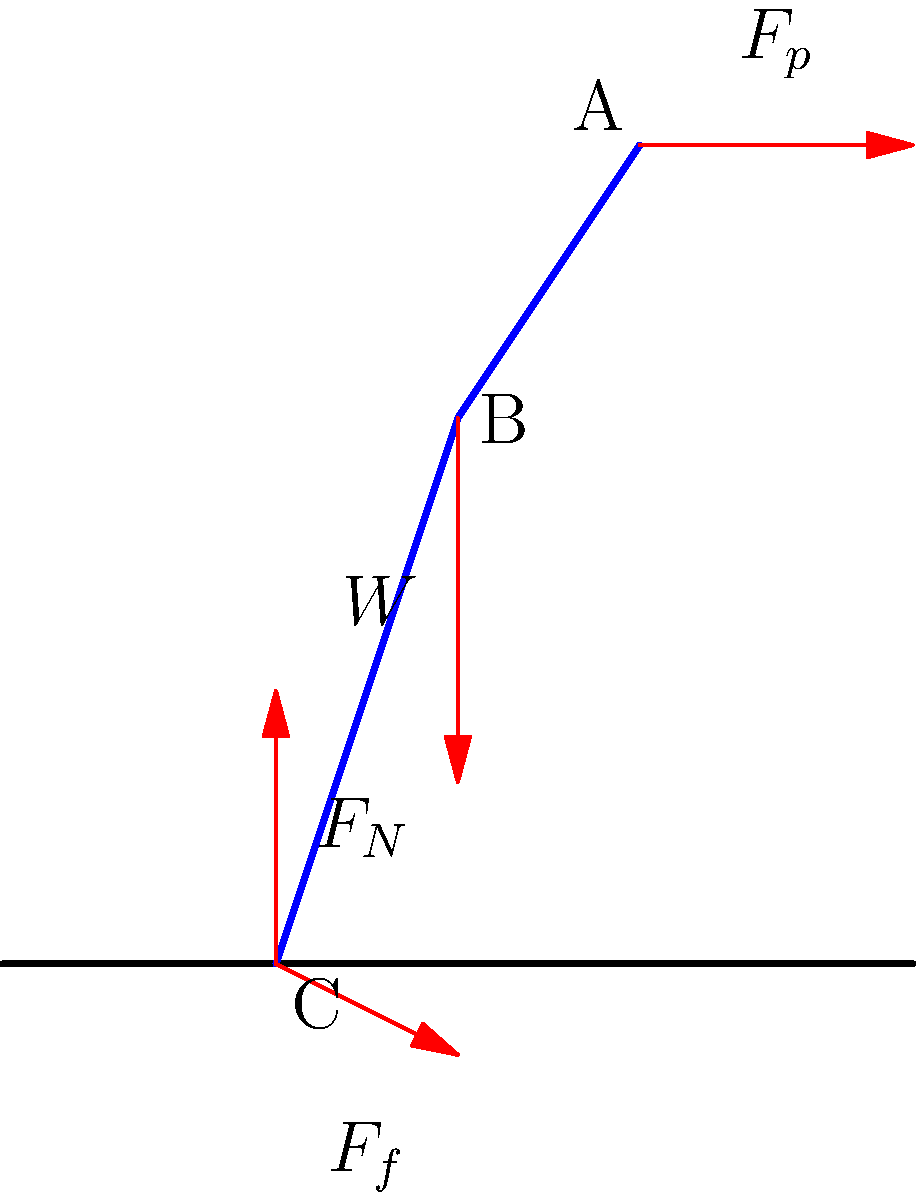In the force diagram of a runner's leg during the stance phase, which force is responsible for propelling the runner forward, and how does it relate to the concept of ground reaction force in biomechanics? To answer this question, let's analyze the force diagram step-by-step:

1. The diagram shows four main forces acting on the runner's leg during the stance phase:
   - $F_N$: Normal force (vertical)
   - $F_f$: Friction force (horizontal)
   - $W$: Weight of the body
   - $F_p$: Propulsive force

2. The ground reaction force (GRF) is the force exerted by the ground on the runner's foot. It can be decomposed into two components:
   - Vertical component: Normal force ($F_N$)
   - Horizontal component: Friction force ($F_f$)

3. The friction force ($F_f$) is the horizontal component of the GRF that opposes the motion of the foot relative to the ground. However, during the propulsive phase of stance, this friction force actually helps propel the runner forward.

4. The propulsive force ($F_p$) shown at the hip joint represents the net force generated by the muscles to move the body forward. This force is ultimately transmitted to the ground through the leg.

5. The interaction between the propulsive force ($F_p$) and the friction force ($F_f$) is crucial for forward motion:
   - As the runner pushes against the ground (applying $F_p$), the ground pushes back with an equal and opposite force (Newton's Third Law).
   - This reaction manifests as the friction force ($F_f$), which, when directed backward, propels the runner forward.

6. The magnitude of the propulsive force depends on factors such as muscle strength, leg positioning, and the coefficient of friction between the foot and the ground.

Therefore, while the propulsive force ($F_p$) generated by the muscles is responsible for initiating the forward motion, it is the friction component of the ground reaction force ($F_f$) that directly propels the runner forward during the stance phase.
Answer: The friction force ($F_f$), as part of the ground reaction force, propels the runner forward in response to the muscular propulsive force ($F_p$). 